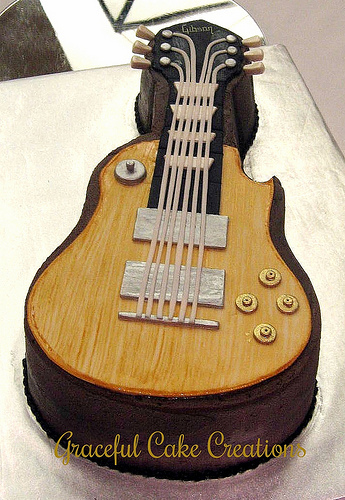<image>
Is there a button under the string? No. The button is not positioned under the string. The vertical relationship between these objects is different. 